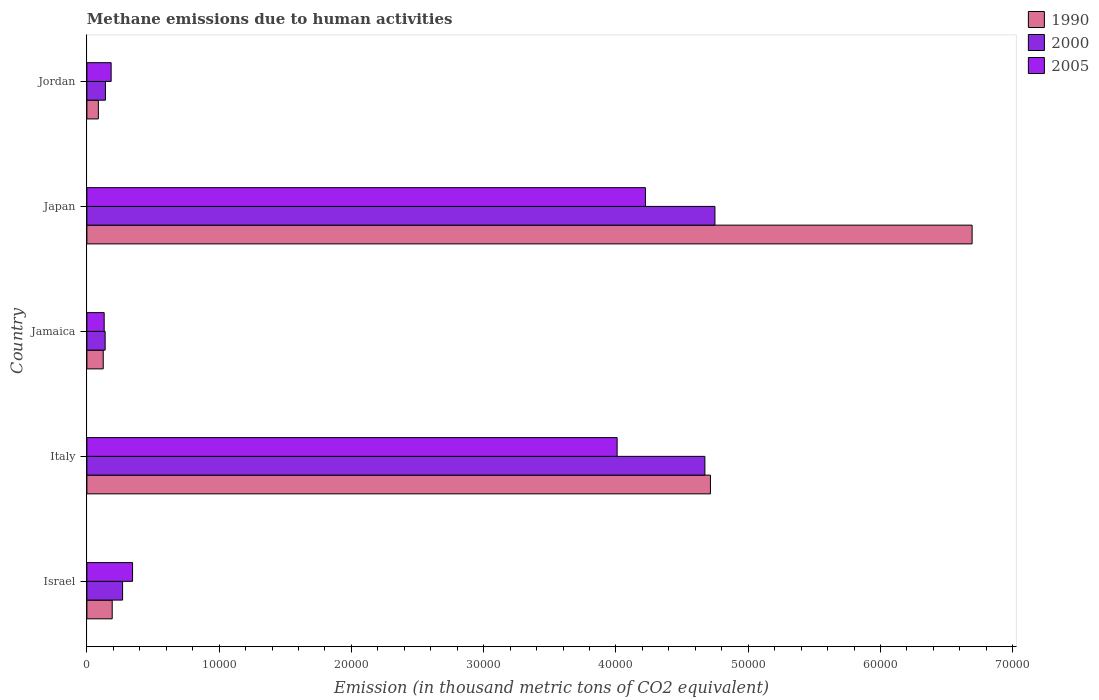Are the number of bars on each tick of the Y-axis equal?
Ensure brevity in your answer.  Yes. In how many cases, is the number of bars for a given country not equal to the number of legend labels?
Keep it short and to the point. 0. What is the amount of methane emitted in 1990 in Japan?
Your answer should be compact. 6.69e+04. Across all countries, what is the maximum amount of methane emitted in 2005?
Your response must be concise. 4.22e+04. Across all countries, what is the minimum amount of methane emitted in 1990?
Offer a terse response. 867.1. In which country was the amount of methane emitted in 1990 maximum?
Keep it short and to the point. Japan. In which country was the amount of methane emitted in 2000 minimum?
Offer a very short reply. Jamaica. What is the total amount of methane emitted in 2005 in the graph?
Your answer should be compact. 8.89e+04. What is the difference between the amount of methane emitted in 2005 in Italy and that in Jamaica?
Provide a short and direct response. 3.88e+04. What is the difference between the amount of methane emitted in 2000 in Italy and the amount of methane emitted in 2005 in Jamaica?
Ensure brevity in your answer.  4.54e+04. What is the average amount of methane emitted in 2005 per country?
Offer a terse response. 1.78e+04. What is the difference between the amount of methane emitted in 1990 and amount of methane emitted in 2000 in Japan?
Offer a terse response. 1.94e+04. What is the ratio of the amount of methane emitted in 2000 in Israel to that in Japan?
Your answer should be compact. 0.06. Is the difference between the amount of methane emitted in 1990 in Jamaica and Japan greater than the difference between the amount of methane emitted in 2000 in Jamaica and Japan?
Make the answer very short. No. What is the difference between the highest and the second highest amount of methane emitted in 2000?
Make the answer very short. 758.6. What is the difference between the highest and the lowest amount of methane emitted in 2000?
Ensure brevity in your answer.  4.61e+04. In how many countries, is the amount of methane emitted in 2005 greater than the average amount of methane emitted in 2005 taken over all countries?
Provide a succinct answer. 2. Is the sum of the amount of methane emitted in 2005 in Israel and Jamaica greater than the maximum amount of methane emitted in 1990 across all countries?
Make the answer very short. No. What does the 2nd bar from the top in Israel represents?
Your response must be concise. 2000. Is it the case that in every country, the sum of the amount of methane emitted in 2000 and amount of methane emitted in 1990 is greater than the amount of methane emitted in 2005?
Offer a terse response. Yes. How many bars are there?
Provide a succinct answer. 15. How many countries are there in the graph?
Your answer should be compact. 5. What is the difference between two consecutive major ticks on the X-axis?
Offer a very short reply. 10000. Are the values on the major ticks of X-axis written in scientific E-notation?
Give a very brief answer. No. Does the graph contain any zero values?
Give a very brief answer. No. Does the graph contain grids?
Make the answer very short. No. Where does the legend appear in the graph?
Your answer should be compact. Top right. How are the legend labels stacked?
Provide a short and direct response. Vertical. What is the title of the graph?
Provide a succinct answer. Methane emissions due to human activities. What is the label or title of the X-axis?
Your response must be concise. Emission (in thousand metric tons of CO2 equivalent). What is the Emission (in thousand metric tons of CO2 equivalent) in 1990 in Israel?
Make the answer very short. 1913. What is the Emission (in thousand metric tons of CO2 equivalent) in 2000 in Israel?
Your answer should be compact. 2698.8. What is the Emission (in thousand metric tons of CO2 equivalent) in 2005 in Israel?
Your response must be concise. 3453.3. What is the Emission (in thousand metric tons of CO2 equivalent) of 1990 in Italy?
Make the answer very short. 4.71e+04. What is the Emission (in thousand metric tons of CO2 equivalent) of 2000 in Italy?
Give a very brief answer. 4.67e+04. What is the Emission (in thousand metric tons of CO2 equivalent) in 2005 in Italy?
Offer a terse response. 4.01e+04. What is the Emission (in thousand metric tons of CO2 equivalent) of 1990 in Jamaica?
Your answer should be very brief. 1235.1. What is the Emission (in thousand metric tons of CO2 equivalent) of 2000 in Jamaica?
Your answer should be compact. 1379.2. What is the Emission (in thousand metric tons of CO2 equivalent) of 2005 in Jamaica?
Give a very brief answer. 1306.5. What is the Emission (in thousand metric tons of CO2 equivalent) in 1990 in Japan?
Your answer should be very brief. 6.69e+04. What is the Emission (in thousand metric tons of CO2 equivalent) of 2000 in Japan?
Provide a succinct answer. 4.75e+04. What is the Emission (in thousand metric tons of CO2 equivalent) in 2005 in Japan?
Keep it short and to the point. 4.22e+04. What is the Emission (in thousand metric tons of CO2 equivalent) in 1990 in Jordan?
Your answer should be very brief. 867.1. What is the Emission (in thousand metric tons of CO2 equivalent) in 2000 in Jordan?
Your answer should be very brief. 1401.8. What is the Emission (in thousand metric tons of CO2 equivalent) of 2005 in Jordan?
Offer a terse response. 1833.2. Across all countries, what is the maximum Emission (in thousand metric tons of CO2 equivalent) in 1990?
Keep it short and to the point. 6.69e+04. Across all countries, what is the maximum Emission (in thousand metric tons of CO2 equivalent) of 2000?
Your answer should be compact. 4.75e+04. Across all countries, what is the maximum Emission (in thousand metric tons of CO2 equivalent) of 2005?
Provide a short and direct response. 4.22e+04. Across all countries, what is the minimum Emission (in thousand metric tons of CO2 equivalent) in 1990?
Your answer should be compact. 867.1. Across all countries, what is the minimum Emission (in thousand metric tons of CO2 equivalent) in 2000?
Your answer should be compact. 1379.2. Across all countries, what is the minimum Emission (in thousand metric tons of CO2 equivalent) of 2005?
Provide a short and direct response. 1306.5. What is the total Emission (in thousand metric tons of CO2 equivalent) of 1990 in the graph?
Offer a very short reply. 1.18e+05. What is the total Emission (in thousand metric tons of CO2 equivalent) in 2000 in the graph?
Your answer should be very brief. 9.97e+04. What is the total Emission (in thousand metric tons of CO2 equivalent) of 2005 in the graph?
Offer a very short reply. 8.89e+04. What is the difference between the Emission (in thousand metric tons of CO2 equivalent) in 1990 in Israel and that in Italy?
Offer a very short reply. -4.52e+04. What is the difference between the Emission (in thousand metric tons of CO2 equivalent) in 2000 in Israel and that in Italy?
Offer a terse response. -4.40e+04. What is the difference between the Emission (in thousand metric tons of CO2 equivalent) of 2005 in Israel and that in Italy?
Offer a terse response. -3.66e+04. What is the difference between the Emission (in thousand metric tons of CO2 equivalent) of 1990 in Israel and that in Jamaica?
Keep it short and to the point. 677.9. What is the difference between the Emission (in thousand metric tons of CO2 equivalent) in 2000 in Israel and that in Jamaica?
Provide a short and direct response. 1319.6. What is the difference between the Emission (in thousand metric tons of CO2 equivalent) in 2005 in Israel and that in Jamaica?
Your response must be concise. 2146.8. What is the difference between the Emission (in thousand metric tons of CO2 equivalent) of 1990 in Israel and that in Japan?
Your answer should be very brief. -6.50e+04. What is the difference between the Emission (in thousand metric tons of CO2 equivalent) in 2000 in Israel and that in Japan?
Provide a succinct answer. -4.48e+04. What is the difference between the Emission (in thousand metric tons of CO2 equivalent) in 2005 in Israel and that in Japan?
Offer a terse response. -3.88e+04. What is the difference between the Emission (in thousand metric tons of CO2 equivalent) in 1990 in Israel and that in Jordan?
Make the answer very short. 1045.9. What is the difference between the Emission (in thousand metric tons of CO2 equivalent) of 2000 in Israel and that in Jordan?
Keep it short and to the point. 1297. What is the difference between the Emission (in thousand metric tons of CO2 equivalent) in 2005 in Israel and that in Jordan?
Provide a succinct answer. 1620.1. What is the difference between the Emission (in thousand metric tons of CO2 equivalent) in 1990 in Italy and that in Jamaica?
Provide a succinct answer. 4.59e+04. What is the difference between the Emission (in thousand metric tons of CO2 equivalent) of 2000 in Italy and that in Jamaica?
Your answer should be compact. 4.53e+04. What is the difference between the Emission (in thousand metric tons of CO2 equivalent) in 2005 in Italy and that in Jamaica?
Provide a short and direct response. 3.88e+04. What is the difference between the Emission (in thousand metric tons of CO2 equivalent) in 1990 in Italy and that in Japan?
Your answer should be compact. -1.98e+04. What is the difference between the Emission (in thousand metric tons of CO2 equivalent) in 2000 in Italy and that in Japan?
Ensure brevity in your answer.  -758.6. What is the difference between the Emission (in thousand metric tons of CO2 equivalent) in 2005 in Italy and that in Japan?
Your response must be concise. -2140.2. What is the difference between the Emission (in thousand metric tons of CO2 equivalent) of 1990 in Italy and that in Jordan?
Your response must be concise. 4.63e+04. What is the difference between the Emission (in thousand metric tons of CO2 equivalent) in 2000 in Italy and that in Jordan?
Make the answer very short. 4.53e+04. What is the difference between the Emission (in thousand metric tons of CO2 equivalent) in 2005 in Italy and that in Jordan?
Offer a very short reply. 3.83e+04. What is the difference between the Emission (in thousand metric tons of CO2 equivalent) of 1990 in Jamaica and that in Japan?
Your response must be concise. -6.57e+04. What is the difference between the Emission (in thousand metric tons of CO2 equivalent) of 2000 in Jamaica and that in Japan?
Provide a succinct answer. -4.61e+04. What is the difference between the Emission (in thousand metric tons of CO2 equivalent) of 2005 in Jamaica and that in Japan?
Ensure brevity in your answer.  -4.09e+04. What is the difference between the Emission (in thousand metric tons of CO2 equivalent) in 1990 in Jamaica and that in Jordan?
Your answer should be very brief. 368. What is the difference between the Emission (in thousand metric tons of CO2 equivalent) of 2000 in Jamaica and that in Jordan?
Your answer should be very brief. -22.6. What is the difference between the Emission (in thousand metric tons of CO2 equivalent) in 2005 in Jamaica and that in Jordan?
Ensure brevity in your answer.  -526.7. What is the difference between the Emission (in thousand metric tons of CO2 equivalent) of 1990 in Japan and that in Jordan?
Your answer should be compact. 6.61e+04. What is the difference between the Emission (in thousand metric tons of CO2 equivalent) in 2000 in Japan and that in Jordan?
Ensure brevity in your answer.  4.61e+04. What is the difference between the Emission (in thousand metric tons of CO2 equivalent) in 2005 in Japan and that in Jordan?
Your answer should be compact. 4.04e+04. What is the difference between the Emission (in thousand metric tons of CO2 equivalent) in 1990 in Israel and the Emission (in thousand metric tons of CO2 equivalent) in 2000 in Italy?
Give a very brief answer. -4.48e+04. What is the difference between the Emission (in thousand metric tons of CO2 equivalent) of 1990 in Israel and the Emission (in thousand metric tons of CO2 equivalent) of 2005 in Italy?
Ensure brevity in your answer.  -3.82e+04. What is the difference between the Emission (in thousand metric tons of CO2 equivalent) of 2000 in Israel and the Emission (in thousand metric tons of CO2 equivalent) of 2005 in Italy?
Ensure brevity in your answer.  -3.74e+04. What is the difference between the Emission (in thousand metric tons of CO2 equivalent) of 1990 in Israel and the Emission (in thousand metric tons of CO2 equivalent) of 2000 in Jamaica?
Give a very brief answer. 533.8. What is the difference between the Emission (in thousand metric tons of CO2 equivalent) of 1990 in Israel and the Emission (in thousand metric tons of CO2 equivalent) of 2005 in Jamaica?
Your answer should be compact. 606.5. What is the difference between the Emission (in thousand metric tons of CO2 equivalent) in 2000 in Israel and the Emission (in thousand metric tons of CO2 equivalent) in 2005 in Jamaica?
Your answer should be compact. 1392.3. What is the difference between the Emission (in thousand metric tons of CO2 equivalent) in 1990 in Israel and the Emission (in thousand metric tons of CO2 equivalent) in 2000 in Japan?
Provide a short and direct response. -4.56e+04. What is the difference between the Emission (in thousand metric tons of CO2 equivalent) in 1990 in Israel and the Emission (in thousand metric tons of CO2 equivalent) in 2005 in Japan?
Give a very brief answer. -4.03e+04. What is the difference between the Emission (in thousand metric tons of CO2 equivalent) of 2000 in Israel and the Emission (in thousand metric tons of CO2 equivalent) of 2005 in Japan?
Keep it short and to the point. -3.95e+04. What is the difference between the Emission (in thousand metric tons of CO2 equivalent) of 1990 in Israel and the Emission (in thousand metric tons of CO2 equivalent) of 2000 in Jordan?
Your response must be concise. 511.2. What is the difference between the Emission (in thousand metric tons of CO2 equivalent) of 1990 in Israel and the Emission (in thousand metric tons of CO2 equivalent) of 2005 in Jordan?
Give a very brief answer. 79.8. What is the difference between the Emission (in thousand metric tons of CO2 equivalent) of 2000 in Israel and the Emission (in thousand metric tons of CO2 equivalent) of 2005 in Jordan?
Make the answer very short. 865.6. What is the difference between the Emission (in thousand metric tons of CO2 equivalent) of 1990 in Italy and the Emission (in thousand metric tons of CO2 equivalent) of 2000 in Jamaica?
Offer a very short reply. 4.58e+04. What is the difference between the Emission (in thousand metric tons of CO2 equivalent) of 1990 in Italy and the Emission (in thousand metric tons of CO2 equivalent) of 2005 in Jamaica?
Your answer should be compact. 4.58e+04. What is the difference between the Emission (in thousand metric tons of CO2 equivalent) in 2000 in Italy and the Emission (in thousand metric tons of CO2 equivalent) in 2005 in Jamaica?
Give a very brief answer. 4.54e+04. What is the difference between the Emission (in thousand metric tons of CO2 equivalent) in 1990 in Italy and the Emission (in thousand metric tons of CO2 equivalent) in 2000 in Japan?
Provide a succinct answer. -339.7. What is the difference between the Emission (in thousand metric tons of CO2 equivalent) of 1990 in Italy and the Emission (in thousand metric tons of CO2 equivalent) of 2005 in Japan?
Your answer should be compact. 4914.3. What is the difference between the Emission (in thousand metric tons of CO2 equivalent) of 2000 in Italy and the Emission (in thousand metric tons of CO2 equivalent) of 2005 in Japan?
Offer a terse response. 4495.4. What is the difference between the Emission (in thousand metric tons of CO2 equivalent) in 1990 in Italy and the Emission (in thousand metric tons of CO2 equivalent) in 2000 in Jordan?
Your answer should be very brief. 4.57e+04. What is the difference between the Emission (in thousand metric tons of CO2 equivalent) of 1990 in Italy and the Emission (in thousand metric tons of CO2 equivalent) of 2005 in Jordan?
Provide a short and direct response. 4.53e+04. What is the difference between the Emission (in thousand metric tons of CO2 equivalent) of 2000 in Italy and the Emission (in thousand metric tons of CO2 equivalent) of 2005 in Jordan?
Your answer should be very brief. 4.49e+04. What is the difference between the Emission (in thousand metric tons of CO2 equivalent) in 1990 in Jamaica and the Emission (in thousand metric tons of CO2 equivalent) in 2000 in Japan?
Give a very brief answer. -4.62e+04. What is the difference between the Emission (in thousand metric tons of CO2 equivalent) of 1990 in Jamaica and the Emission (in thousand metric tons of CO2 equivalent) of 2005 in Japan?
Your response must be concise. -4.10e+04. What is the difference between the Emission (in thousand metric tons of CO2 equivalent) in 2000 in Jamaica and the Emission (in thousand metric tons of CO2 equivalent) in 2005 in Japan?
Provide a succinct answer. -4.09e+04. What is the difference between the Emission (in thousand metric tons of CO2 equivalent) of 1990 in Jamaica and the Emission (in thousand metric tons of CO2 equivalent) of 2000 in Jordan?
Offer a terse response. -166.7. What is the difference between the Emission (in thousand metric tons of CO2 equivalent) of 1990 in Jamaica and the Emission (in thousand metric tons of CO2 equivalent) of 2005 in Jordan?
Offer a very short reply. -598.1. What is the difference between the Emission (in thousand metric tons of CO2 equivalent) in 2000 in Jamaica and the Emission (in thousand metric tons of CO2 equivalent) in 2005 in Jordan?
Keep it short and to the point. -454. What is the difference between the Emission (in thousand metric tons of CO2 equivalent) of 1990 in Japan and the Emission (in thousand metric tons of CO2 equivalent) of 2000 in Jordan?
Offer a terse response. 6.55e+04. What is the difference between the Emission (in thousand metric tons of CO2 equivalent) in 1990 in Japan and the Emission (in thousand metric tons of CO2 equivalent) in 2005 in Jordan?
Offer a terse response. 6.51e+04. What is the difference between the Emission (in thousand metric tons of CO2 equivalent) in 2000 in Japan and the Emission (in thousand metric tons of CO2 equivalent) in 2005 in Jordan?
Provide a succinct answer. 4.57e+04. What is the average Emission (in thousand metric tons of CO2 equivalent) of 1990 per country?
Provide a succinct answer. 2.36e+04. What is the average Emission (in thousand metric tons of CO2 equivalent) in 2000 per country?
Your response must be concise. 1.99e+04. What is the average Emission (in thousand metric tons of CO2 equivalent) in 2005 per country?
Ensure brevity in your answer.  1.78e+04. What is the difference between the Emission (in thousand metric tons of CO2 equivalent) of 1990 and Emission (in thousand metric tons of CO2 equivalent) of 2000 in Israel?
Your answer should be compact. -785.8. What is the difference between the Emission (in thousand metric tons of CO2 equivalent) in 1990 and Emission (in thousand metric tons of CO2 equivalent) in 2005 in Israel?
Keep it short and to the point. -1540.3. What is the difference between the Emission (in thousand metric tons of CO2 equivalent) in 2000 and Emission (in thousand metric tons of CO2 equivalent) in 2005 in Israel?
Provide a short and direct response. -754.5. What is the difference between the Emission (in thousand metric tons of CO2 equivalent) in 1990 and Emission (in thousand metric tons of CO2 equivalent) in 2000 in Italy?
Give a very brief answer. 418.9. What is the difference between the Emission (in thousand metric tons of CO2 equivalent) of 1990 and Emission (in thousand metric tons of CO2 equivalent) of 2005 in Italy?
Your answer should be compact. 7054.5. What is the difference between the Emission (in thousand metric tons of CO2 equivalent) in 2000 and Emission (in thousand metric tons of CO2 equivalent) in 2005 in Italy?
Offer a very short reply. 6635.6. What is the difference between the Emission (in thousand metric tons of CO2 equivalent) in 1990 and Emission (in thousand metric tons of CO2 equivalent) in 2000 in Jamaica?
Ensure brevity in your answer.  -144.1. What is the difference between the Emission (in thousand metric tons of CO2 equivalent) of 1990 and Emission (in thousand metric tons of CO2 equivalent) of 2005 in Jamaica?
Keep it short and to the point. -71.4. What is the difference between the Emission (in thousand metric tons of CO2 equivalent) in 2000 and Emission (in thousand metric tons of CO2 equivalent) in 2005 in Jamaica?
Your answer should be very brief. 72.7. What is the difference between the Emission (in thousand metric tons of CO2 equivalent) in 1990 and Emission (in thousand metric tons of CO2 equivalent) in 2000 in Japan?
Your answer should be compact. 1.94e+04. What is the difference between the Emission (in thousand metric tons of CO2 equivalent) in 1990 and Emission (in thousand metric tons of CO2 equivalent) in 2005 in Japan?
Your response must be concise. 2.47e+04. What is the difference between the Emission (in thousand metric tons of CO2 equivalent) in 2000 and Emission (in thousand metric tons of CO2 equivalent) in 2005 in Japan?
Offer a very short reply. 5254. What is the difference between the Emission (in thousand metric tons of CO2 equivalent) in 1990 and Emission (in thousand metric tons of CO2 equivalent) in 2000 in Jordan?
Your answer should be very brief. -534.7. What is the difference between the Emission (in thousand metric tons of CO2 equivalent) of 1990 and Emission (in thousand metric tons of CO2 equivalent) of 2005 in Jordan?
Your answer should be very brief. -966.1. What is the difference between the Emission (in thousand metric tons of CO2 equivalent) in 2000 and Emission (in thousand metric tons of CO2 equivalent) in 2005 in Jordan?
Your answer should be very brief. -431.4. What is the ratio of the Emission (in thousand metric tons of CO2 equivalent) in 1990 in Israel to that in Italy?
Offer a terse response. 0.04. What is the ratio of the Emission (in thousand metric tons of CO2 equivalent) in 2000 in Israel to that in Italy?
Offer a very short reply. 0.06. What is the ratio of the Emission (in thousand metric tons of CO2 equivalent) of 2005 in Israel to that in Italy?
Make the answer very short. 0.09. What is the ratio of the Emission (in thousand metric tons of CO2 equivalent) of 1990 in Israel to that in Jamaica?
Your answer should be very brief. 1.55. What is the ratio of the Emission (in thousand metric tons of CO2 equivalent) in 2000 in Israel to that in Jamaica?
Make the answer very short. 1.96. What is the ratio of the Emission (in thousand metric tons of CO2 equivalent) of 2005 in Israel to that in Jamaica?
Offer a very short reply. 2.64. What is the ratio of the Emission (in thousand metric tons of CO2 equivalent) in 1990 in Israel to that in Japan?
Ensure brevity in your answer.  0.03. What is the ratio of the Emission (in thousand metric tons of CO2 equivalent) of 2000 in Israel to that in Japan?
Your answer should be compact. 0.06. What is the ratio of the Emission (in thousand metric tons of CO2 equivalent) of 2005 in Israel to that in Japan?
Offer a very short reply. 0.08. What is the ratio of the Emission (in thousand metric tons of CO2 equivalent) in 1990 in Israel to that in Jordan?
Ensure brevity in your answer.  2.21. What is the ratio of the Emission (in thousand metric tons of CO2 equivalent) in 2000 in Israel to that in Jordan?
Your response must be concise. 1.93. What is the ratio of the Emission (in thousand metric tons of CO2 equivalent) of 2005 in Israel to that in Jordan?
Offer a terse response. 1.88. What is the ratio of the Emission (in thousand metric tons of CO2 equivalent) in 1990 in Italy to that in Jamaica?
Offer a terse response. 38.17. What is the ratio of the Emission (in thousand metric tons of CO2 equivalent) of 2000 in Italy to that in Jamaica?
Your response must be concise. 33.88. What is the ratio of the Emission (in thousand metric tons of CO2 equivalent) in 2005 in Italy to that in Jamaica?
Make the answer very short. 30.68. What is the ratio of the Emission (in thousand metric tons of CO2 equivalent) in 1990 in Italy to that in Japan?
Offer a very short reply. 0.7. What is the ratio of the Emission (in thousand metric tons of CO2 equivalent) of 2005 in Italy to that in Japan?
Make the answer very short. 0.95. What is the ratio of the Emission (in thousand metric tons of CO2 equivalent) of 1990 in Italy to that in Jordan?
Provide a succinct answer. 54.37. What is the ratio of the Emission (in thousand metric tons of CO2 equivalent) of 2000 in Italy to that in Jordan?
Your response must be concise. 33.33. What is the ratio of the Emission (in thousand metric tons of CO2 equivalent) of 2005 in Italy to that in Jordan?
Keep it short and to the point. 21.87. What is the ratio of the Emission (in thousand metric tons of CO2 equivalent) in 1990 in Jamaica to that in Japan?
Your response must be concise. 0.02. What is the ratio of the Emission (in thousand metric tons of CO2 equivalent) in 2000 in Jamaica to that in Japan?
Ensure brevity in your answer.  0.03. What is the ratio of the Emission (in thousand metric tons of CO2 equivalent) in 2005 in Jamaica to that in Japan?
Offer a very short reply. 0.03. What is the ratio of the Emission (in thousand metric tons of CO2 equivalent) in 1990 in Jamaica to that in Jordan?
Provide a succinct answer. 1.42. What is the ratio of the Emission (in thousand metric tons of CO2 equivalent) of 2000 in Jamaica to that in Jordan?
Keep it short and to the point. 0.98. What is the ratio of the Emission (in thousand metric tons of CO2 equivalent) in 2005 in Jamaica to that in Jordan?
Give a very brief answer. 0.71. What is the ratio of the Emission (in thousand metric tons of CO2 equivalent) of 1990 in Japan to that in Jordan?
Your answer should be very brief. 77.19. What is the ratio of the Emission (in thousand metric tons of CO2 equivalent) of 2000 in Japan to that in Jordan?
Your answer should be very brief. 33.87. What is the ratio of the Emission (in thousand metric tons of CO2 equivalent) in 2005 in Japan to that in Jordan?
Your answer should be very brief. 23.04. What is the difference between the highest and the second highest Emission (in thousand metric tons of CO2 equivalent) in 1990?
Provide a short and direct response. 1.98e+04. What is the difference between the highest and the second highest Emission (in thousand metric tons of CO2 equivalent) of 2000?
Offer a terse response. 758.6. What is the difference between the highest and the second highest Emission (in thousand metric tons of CO2 equivalent) of 2005?
Keep it short and to the point. 2140.2. What is the difference between the highest and the lowest Emission (in thousand metric tons of CO2 equivalent) of 1990?
Your answer should be compact. 6.61e+04. What is the difference between the highest and the lowest Emission (in thousand metric tons of CO2 equivalent) in 2000?
Keep it short and to the point. 4.61e+04. What is the difference between the highest and the lowest Emission (in thousand metric tons of CO2 equivalent) in 2005?
Offer a very short reply. 4.09e+04. 